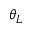<formula> <loc_0><loc_0><loc_500><loc_500>\theta _ { L }</formula> 